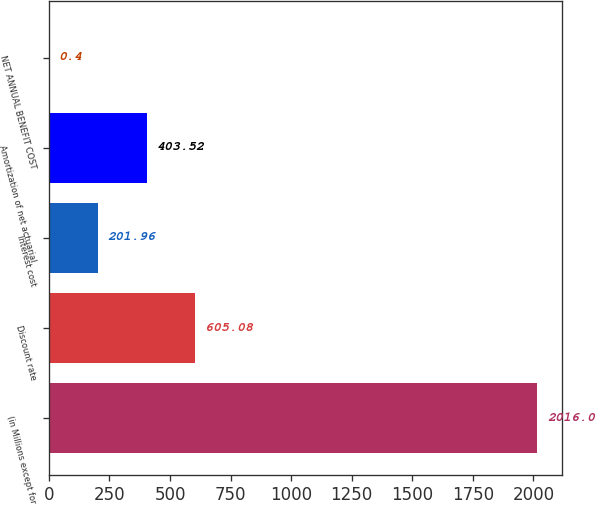<chart> <loc_0><loc_0><loc_500><loc_500><bar_chart><fcel>(in Millions except for<fcel>Discount rate<fcel>Interest cost<fcel>Amortization of net actuarial<fcel>NET ANNUAL BENEFIT COST<nl><fcel>2016<fcel>605.08<fcel>201.96<fcel>403.52<fcel>0.4<nl></chart> 